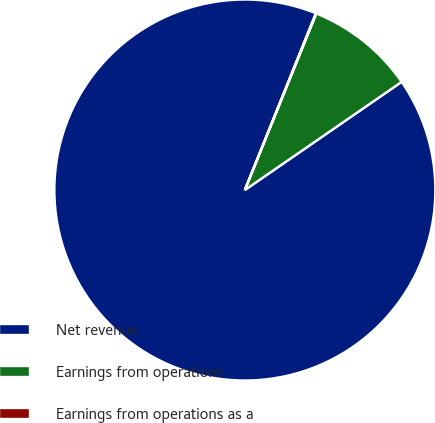Convert chart to OTSL. <chart><loc_0><loc_0><loc_500><loc_500><pie_chart><fcel>Net revenue<fcel>Earnings from operations<fcel>Earnings from operations as a<nl><fcel>90.7%<fcel>9.27%<fcel>0.04%<nl></chart> 